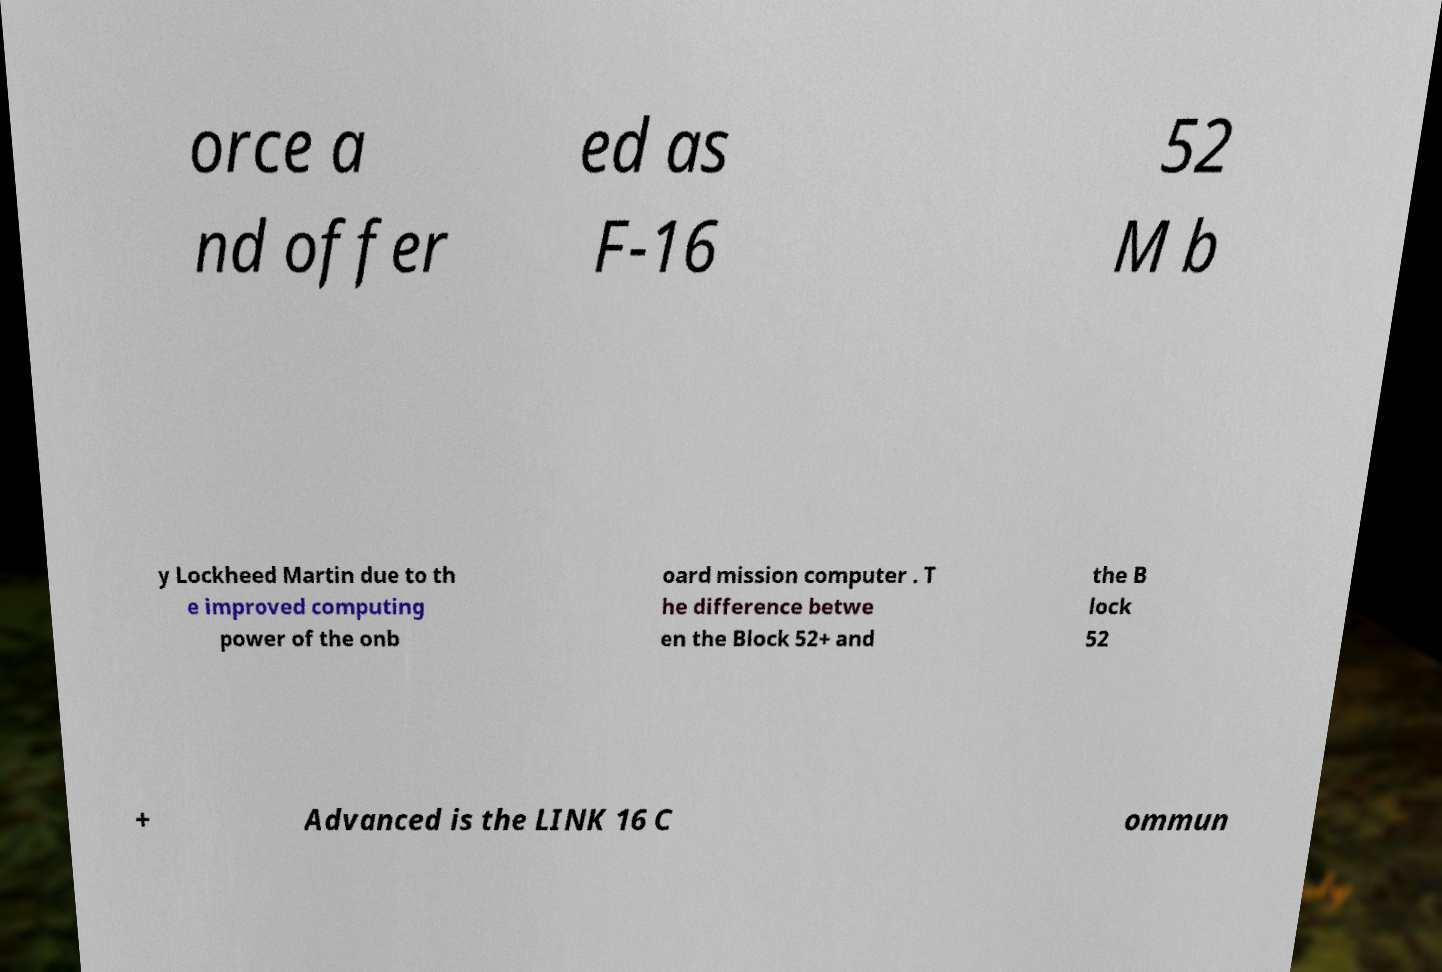Can you accurately transcribe the text from the provided image for me? orce a nd offer ed as F-16 52 M b y Lockheed Martin due to th e improved computing power of the onb oard mission computer . T he difference betwe en the Block 52+ and the B lock 52 + Advanced is the LINK 16 C ommun 